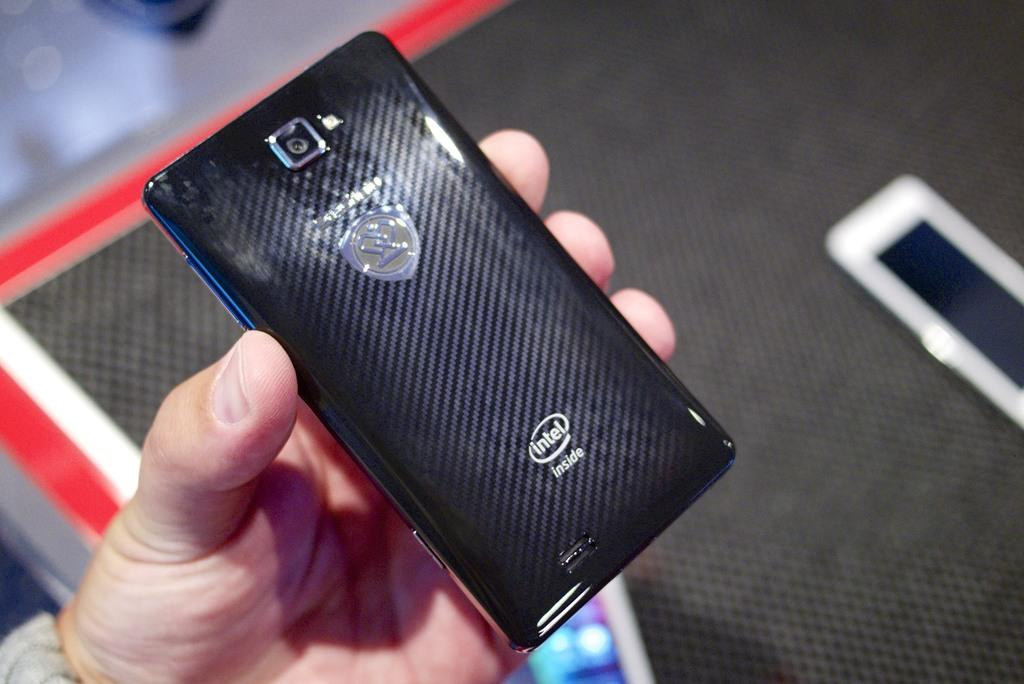Provide a one-sentence caption for the provided image. Someone holding an Intel phone in their hand. 